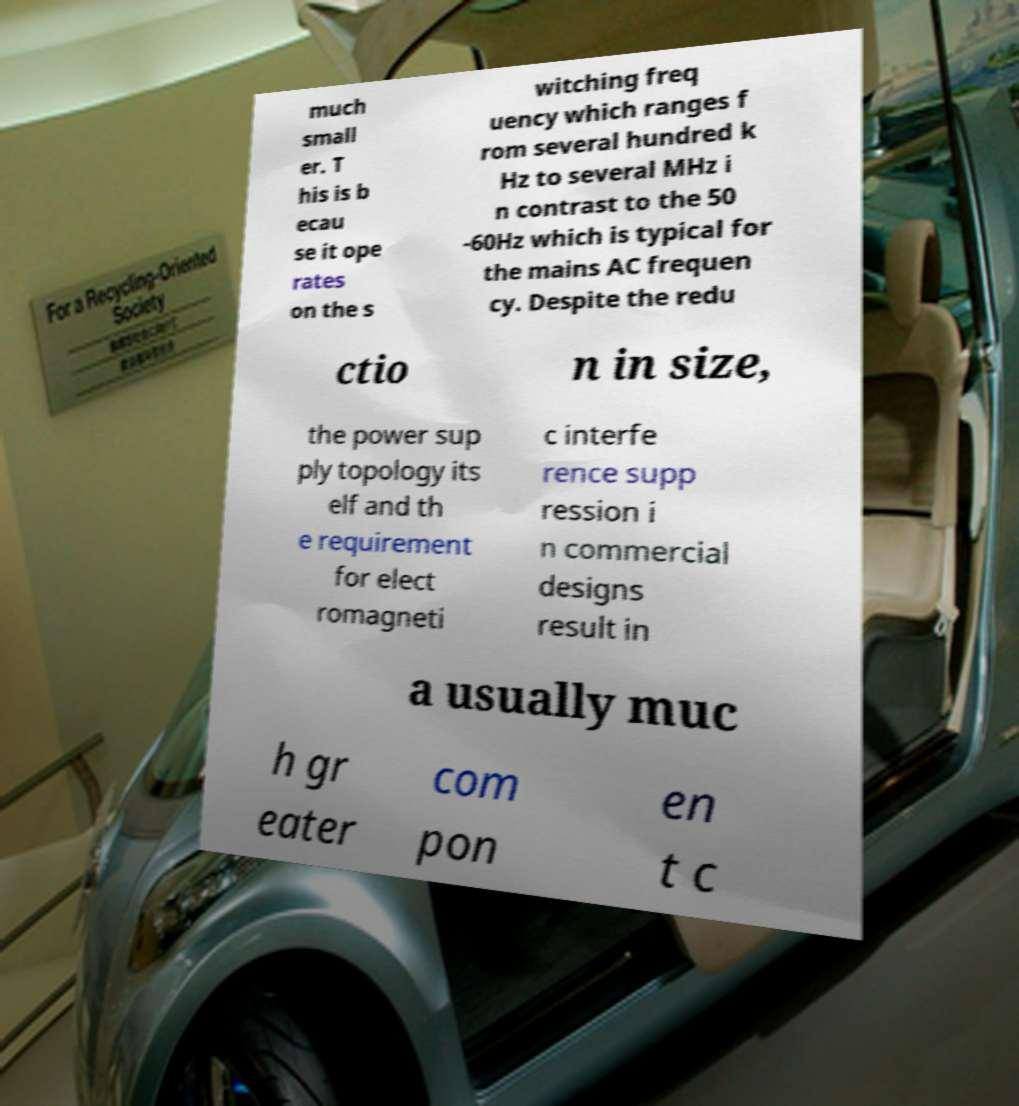Could you extract and type out the text from this image? much small er. T his is b ecau se it ope rates on the s witching freq uency which ranges f rom several hundred k Hz to several MHz i n contrast to the 50 -60Hz which is typical for the mains AC frequen cy. Despite the redu ctio n in size, the power sup ply topology its elf and th e requirement for elect romagneti c interfe rence supp ression i n commercial designs result in a usually muc h gr eater com pon en t c 